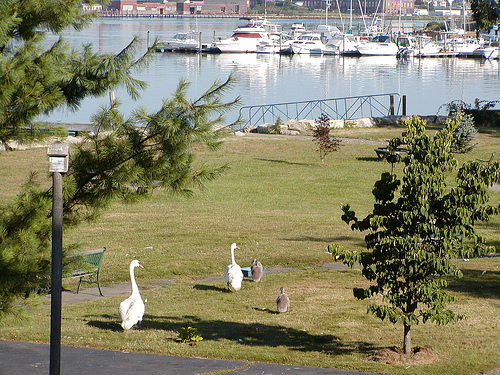<image>
Is there a goose next to the duck? No. The goose is not positioned next to the duck. They are located in different areas of the scene. 